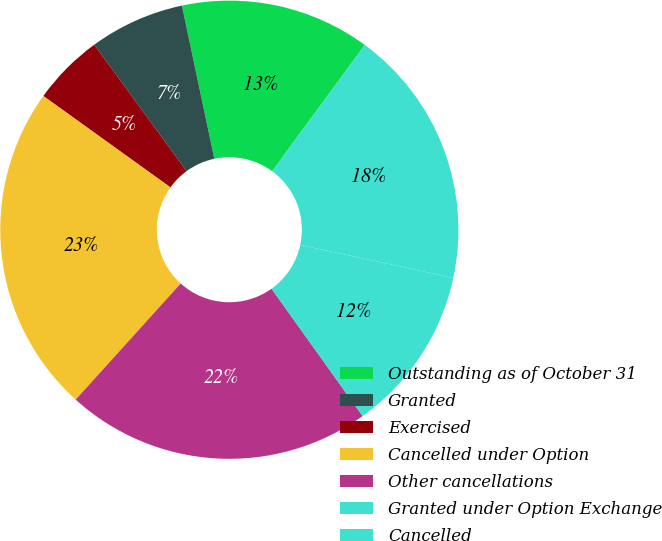Convert chart. <chart><loc_0><loc_0><loc_500><loc_500><pie_chart><fcel>Outstanding as of October 31<fcel>Granted<fcel>Exercised<fcel>Cancelled under Option<fcel>Other cancellations<fcel>Granted under Option Exchange<fcel>Cancelled<nl><fcel>13.39%<fcel>6.72%<fcel>5.04%<fcel>23.22%<fcel>21.58%<fcel>11.75%<fcel>18.3%<nl></chart> 